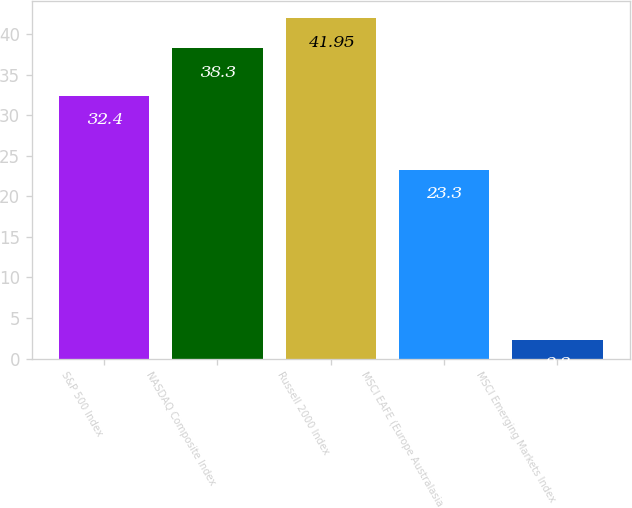Convert chart to OTSL. <chart><loc_0><loc_0><loc_500><loc_500><bar_chart><fcel>S&P 500 Index<fcel>NASDAQ Composite Index<fcel>Russell 2000 Index<fcel>MSCI EAFE (Europe Australasia<fcel>MSCI Emerging Markets Index<nl><fcel>32.4<fcel>38.3<fcel>41.95<fcel>23.3<fcel>2.3<nl></chart> 